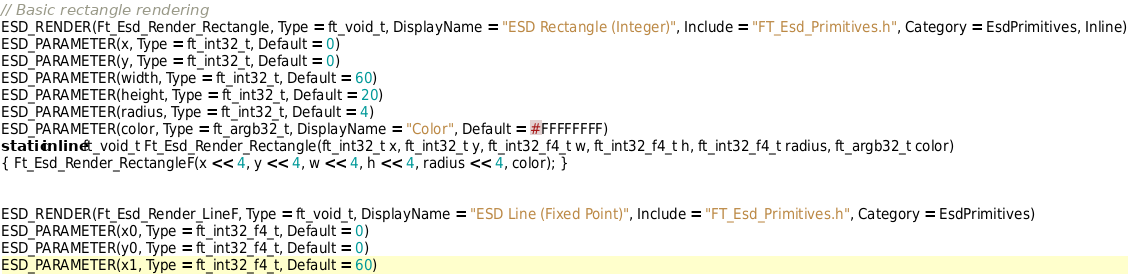Convert code to text. <code><loc_0><loc_0><loc_500><loc_500><_C_>// Basic rectangle rendering
ESD_RENDER(Ft_Esd_Render_Rectangle, Type = ft_void_t, DisplayName = "ESD Rectangle (Integer)", Include = "FT_Esd_Primitives.h", Category = EsdPrimitives, Inline)
ESD_PARAMETER(x, Type = ft_int32_t, Default = 0)
ESD_PARAMETER(y, Type = ft_int32_t, Default = 0)
ESD_PARAMETER(width, Type = ft_int32_t, Default = 60)
ESD_PARAMETER(height, Type = ft_int32_t, Default = 20)
ESD_PARAMETER(radius, Type = ft_int32_t, Default = 4)
ESD_PARAMETER(color, Type = ft_argb32_t, DisplayName = "Color", Default = #FFFFFFFF)
static inline ft_void_t Ft_Esd_Render_Rectangle(ft_int32_t x, ft_int32_t y, ft_int32_f4_t w, ft_int32_f4_t h, ft_int32_f4_t radius, ft_argb32_t color)
{ Ft_Esd_Render_RectangleF(x << 4, y << 4, w << 4, h << 4, radius << 4, color); }


ESD_RENDER(Ft_Esd_Render_LineF, Type = ft_void_t, DisplayName = "ESD Line (Fixed Point)", Include = "FT_Esd_Primitives.h", Category = EsdPrimitives)
ESD_PARAMETER(x0, Type = ft_int32_f4_t, Default = 0)
ESD_PARAMETER(y0, Type = ft_int32_f4_t, Default = 0)
ESD_PARAMETER(x1, Type = ft_int32_f4_t, Default = 60)</code> 